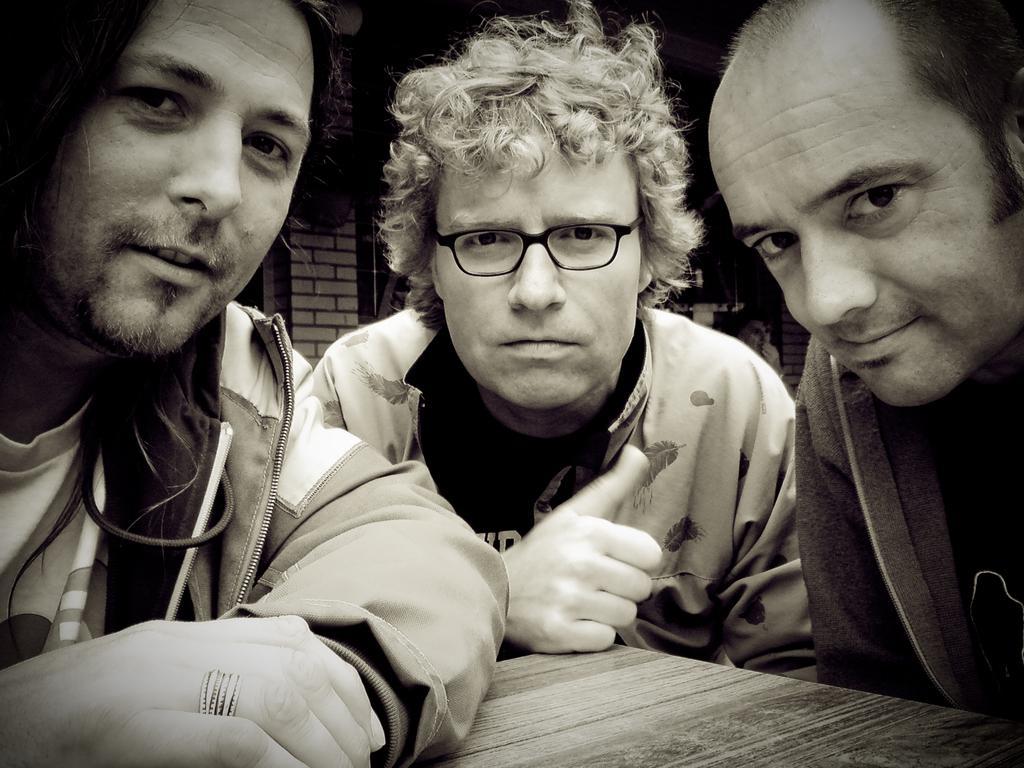Please provide a concise description of this image. In this image on the right, there is a man, he wears a jacket. In the middle there is a man, he wears a jacket, t shirt. On the left there is a man, he wears a jacket, t shirt. At the bottom there is a table. In the background there is a house. 